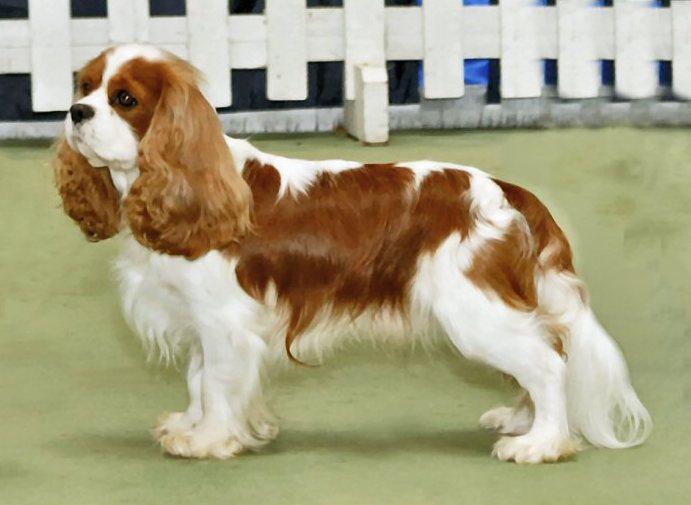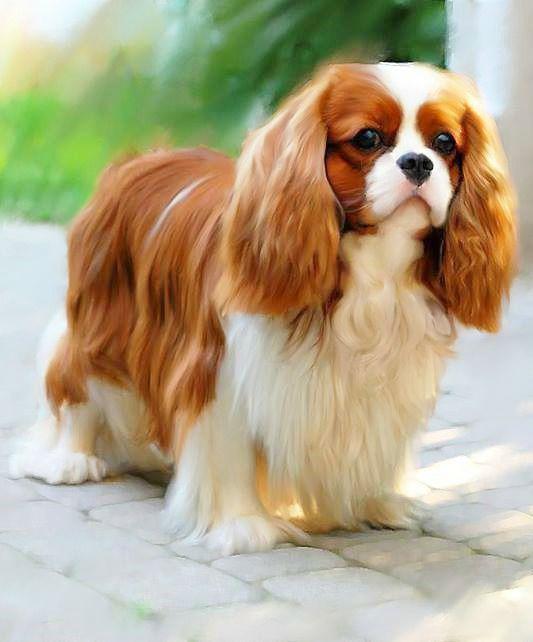The first image is the image on the left, the second image is the image on the right. Considering the images on both sides, is "Left and right images feature one dog on the same type of surface as in the other image." valid? Answer yes or no. No. The first image is the image on the left, the second image is the image on the right. Analyze the images presented: Is the assertion "The dog on the right is standing in the green grass outside." valid? Answer yes or no. No. 